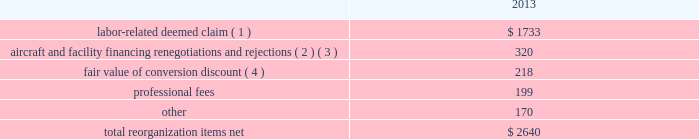Table of contents interest expense , net of capitalized interest decreased $ 129 million , or 18.1% ( 18.1 % ) , in 2014 from the 2013 period primarily due to a $ 63 million decrease in special charges recognized period-over-period as further described below , as well as refinancing activities that resulted in $ 65 million less interest expense recognized in 2014 .
In 2014 , american recognized $ 29 million of special charges relating to non-cash interest accretion on bankruptcy settlement obligations .
In 2013 , american recognized $ 48 million of special charges relating to post-petition interest expense on unsecured obligations pursuant to the plan and penalty interest related to american 2019s 10.5% ( 10.5 % ) secured notes and 7.50% ( 7.50 % ) senior secured notes .
In addition , in 2013 american recorded special charges of $ 44 million for debt extinguishment costs incurred as a result of the repayment of certain aircraft secured indebtedness , including cash interest charges and non-cash write offs of unamortized debt issuance costs .
As a result of the 2013 refinancing activities and the early extinguishment of american 2019s 7.50% ( 7.50 % ) senior secured notes in 2014 , american recognized $ 65 million less interest expense in 2014 as compared to the 2013 period .
Other nonoperating expense , net of $ 153 million in 2014 consisted principally of net foreign currency losses of $ 92 million and early debt extinguishment charges of $ 48 million .
Other nonoperating expense , net of $ 84 million in 2013 consisted principally of net foreign currency losses of $ 55 million and early debt extinguishment charges of $ 29 million .
Other nonoperating expense , net increased $ 69 million , or 81.0% ( 81.0 % ) , during 2014 primarily due to special charges recognized as a result of early debt extinguishment and an increase in foreign currency losses driven by the strengthening of the u.s .
Dollar in foreign currency transactions , principally in latin american markets .
American recorded a $ 43 million special charge for venezuelan foreign currency losses in 2014 .
See part ii , item 7a .
Quantitative and qualitative disclosures about market risk for further discussion of our cash held in venezuelan bolivars .
In addition , american 2019s nonoperating special items included $ 48 million in special charges in the 2014 primarily related to the early extinguishment of american 2019s 7.50% ( 7.50 % ) senior secured notes and other indebtedness .
Reorganization items , net reorganization items refer to revenues , expenses ( including professional fees ) , realized gains and losses and provisions for losses that are realized or incurred as a direct result of the chapter 11 cases .
The table summarizes the components included in reorganization items , net on american 2019s consolidated statement of operations for the year ended december 31 , 2013 ( in millions ) : .
( 1 ) in exchange for employees 2019 contributions to the successful reorganization , including agreeing to reductions in pay and benefits , american agreed in the plan to provide each employee group a deemed claim , which was used to provide a distribution of a portion of the equity of the reorganized entity to those employees .
Each employee group received a deemed claim amount based upon a portion of the value of cost savings provided by that group through reductions to pay and benefits as well as through certain work rule changes .
The total value of this deemed claim was approximately $ 1.7 billion .
( 2 ) amounts include allowed claims ( claims approved by the bankruptcy court ) and estimated allowed claims relating to ( i ) the rejection or modification of financings related to aircraft and ( ii ) entry of orders treated as unsecured claims with respect to facility agreements supporting certain issuances of special facility revenue bonds .
The debtors recorded an estimated claim associated with the rejection or modification of a financing or facility agreement when the applicable motion was filed with the bankruptcy court to reject or modify .
What percentage of total reorganization items net consisted of labor-related deemed claim? 
Computations: (1733 / 2640)
Answer: 0.65644. 